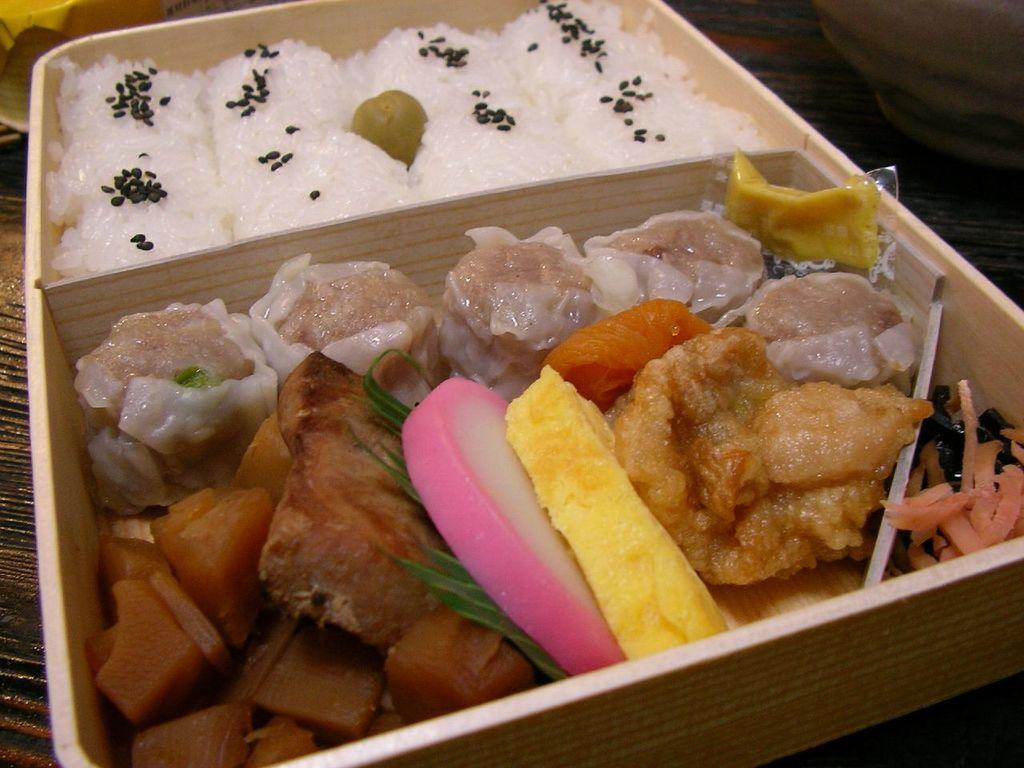Can you describe this image briefly? In this image we can see a box on a surface. In the box there is rice with sesame seeds and some other thing. Also there are some other food items. 